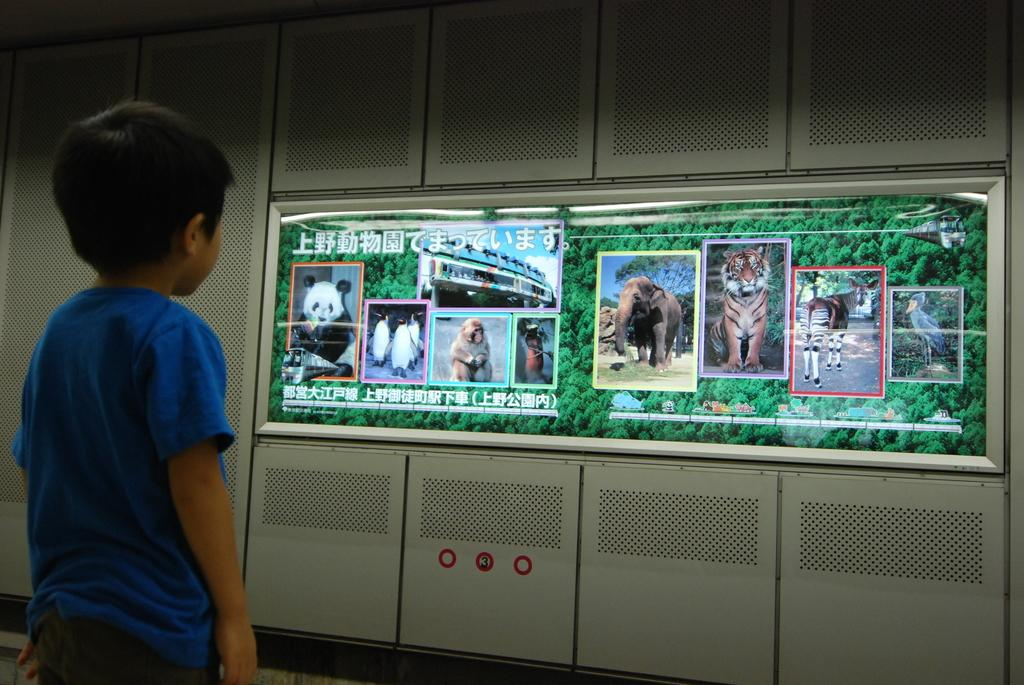What type of furniture is visible in the image? There are cupboards in the image. What electronic device is present in the image? There is a screen in the image. Can you describe the boy in the image? The boy is present in the image, wearing a blue color t-shirt. What is displayed on the screen? The screen displays trees and different types of animals. How many girls are present in the image? There are no girls mentioned or visible in the image. What type of comb is the boy using in the image? There is no comb present in the image. 